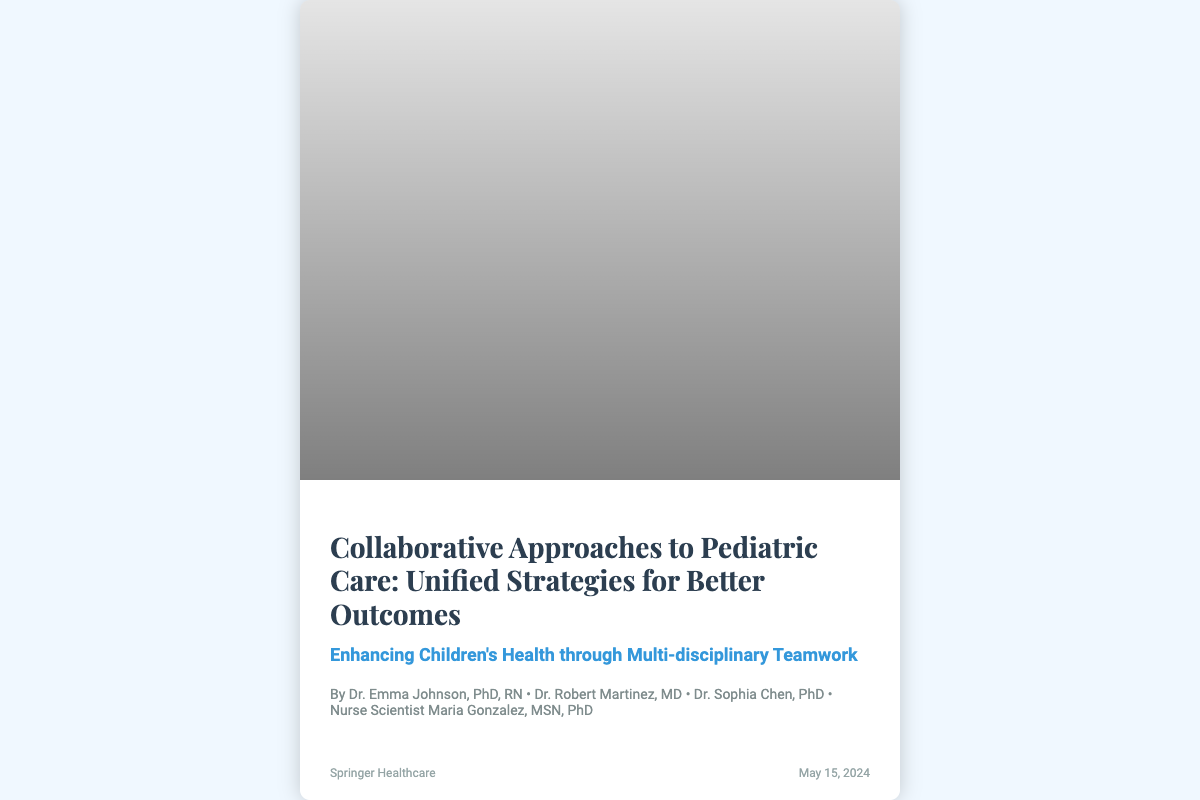What is the title of the book? The title is prominently displayed on the cover of the book.
Answer: Collaborative Approaches to Pediatric Care: Unified Strategies for Better Outcomes Who are the authors of the book? The authors' names are listed below the title in the content section of the cover.
Answer: Dr. Emma Johnson, PhD, RN; Dr. Robert Martinez, MD; Dr. Sophia Chen, PhD; Nurse Scientist Maria Gonzalez, MSN, PhD What is the publisher's name? The publisher's name is presented in the footer of the book cover.
Answer: Springer Healthcare When is the publication date? The publication date is also found in the footer section, next to the publisher's name.
Answer: May 15, 2024 What theme does the subtitle of the book suggest? The subtitle indicates the focus of the book content related to teamwork and health improvements.
Answer: Enhancing Children's Health through Multi-disciplinary Teamwork What visual elements are depicted on the cover? The image of healthcare professionals and children suggests a collaborative environment in pediatric care.
Answer: A team of healthcare professionals and researchers How does the cover design support the book's theme? The cover design illustrates collaboration, which is central to the book's message about pediatric care.
Answer: It visually represents teamwork and pediatric health intervention What is the target demographic suggested by the book's cover? The presence of children playing in the background clearly indicates the focus on pediatric healthcare.
Answer: Pediatric population 